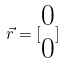<formula> <loc_0><loc_0><loc_500><loc_500>\vec { r } = [ \begin{matrix} 0 \\ 0 \end{matrix} ]</formula> 